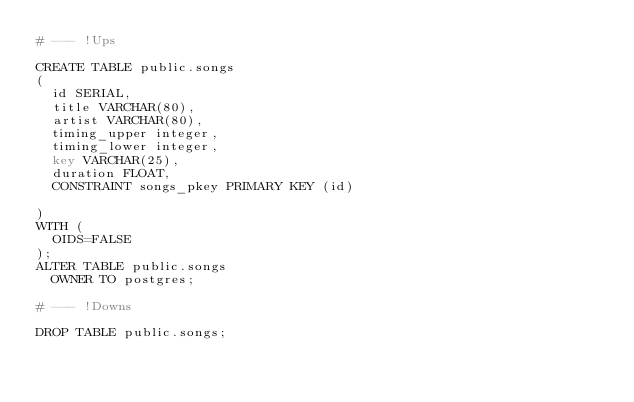Convert code to text. <code><loc_0><loc_0><loc_500><loc_500><_SQL_># --- !Ups

CREATE TABLE public.songs
(
  id SERIAL,
  title VARCHAR(80),
  artist VARCHAR(80),
  timing_upper integer,
  timing_lower integer,
  key VARCHAR(25),
  duration FLOAT,
  CONSTRAINT songs_pkey PRIMARY KEY (id)

)
WITH (
  OIDS=FALSE
);
ALTER TABLE public.songs
  OWNER TO postgres;

# --- !Downs

DROP TABLE public.songs;</code> 